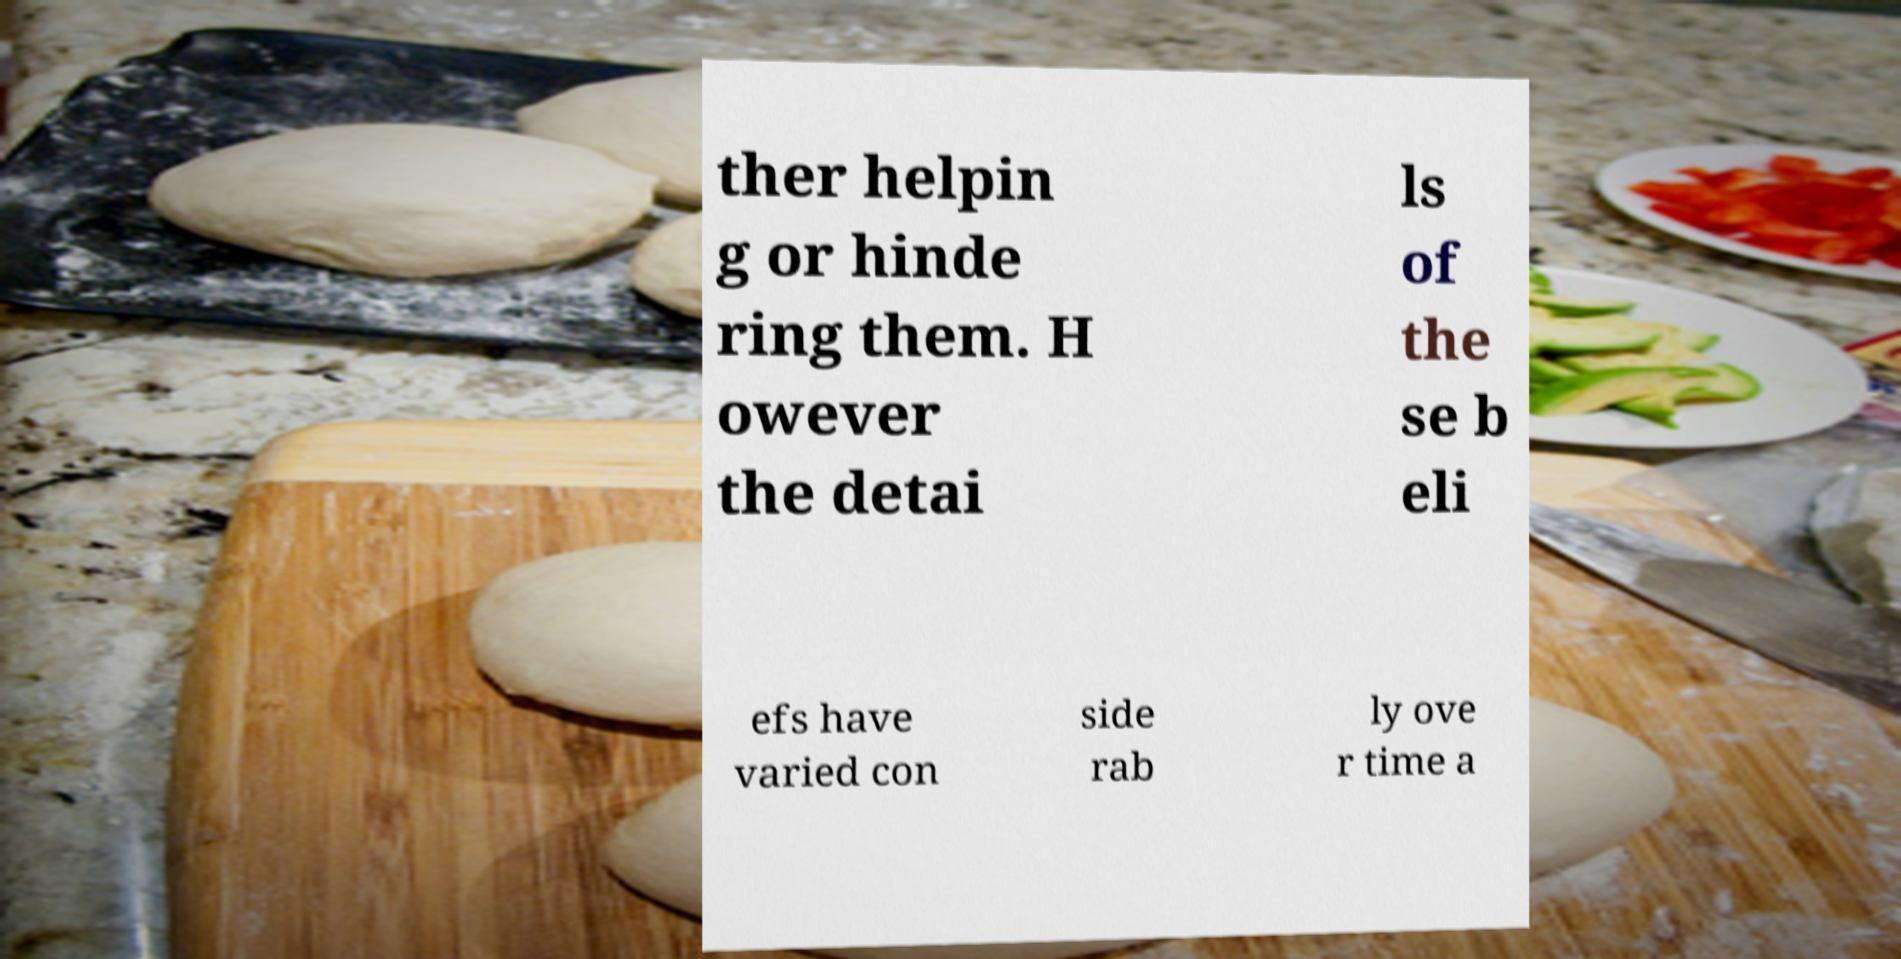Please identify and transcribe the text found in this image. ther helpin g or hinde ring them. H owever the detai ls of the se b eli efs have varied con side rab ly ove r time a 